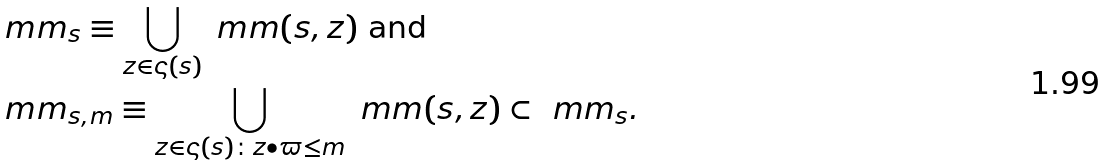Convert formula to latex. <formula><loc_0><loc_0><loc_500><loc_500>& \ m m _ { s } \equiv \bigcup _ { z \in \varsigma ( s ) } \ m m ( { s } , z ) \text { and} \\ & \ m m _ { s , m } \equiv \bigcup _ { z \in \varsigma ( s ) \colon z \bullet \varpi \leq m } \ m m ( { s } , z ) \subset \ m m _ { s } .</formula> 